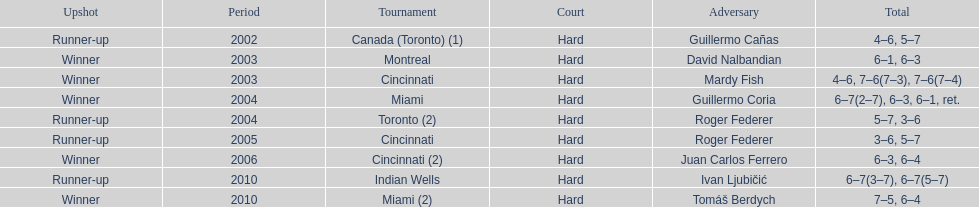Did roddick have more runner-up finishes or victories? Winner. 